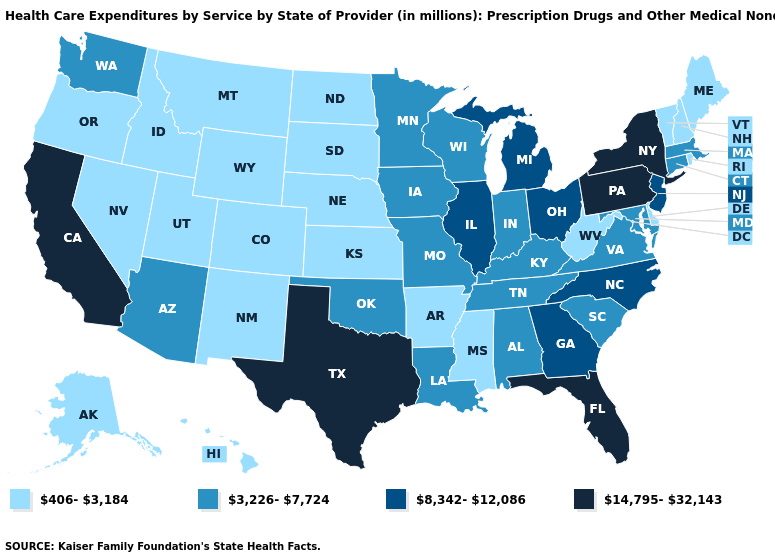Is the legend a continuous bar?
Concise answer only. No. What is the value of Maryland?
Give a very brief answer. 3,226-7,724. What is the value of Nebraska?
Be succinct. 406-3,184. What is the highest value in states that border Delaware?
Quick response, please. 14,795-32,143. Does Pennsylvania have the highest value in the Northeast?
Keep it brief. Yes. What is the highest value in the South ?
Be succinct. 14,795-32,143. Name the states that have a value in the range 406-3,184?
Give a very brief answer. Alaska, Arkansas, Colorado, Delaware, Hawaii, Idaho, Kansas, Maine, Mississippi, Montana, Nebraska, Nevada, New Hampshire, New Mexico, North Dakota, Oregon, Rhode Island, South Dakota, Utah, Vermont, West Virginia, Wyoming. Among the states that border Maryland , does Delaware have the lowest value?
Keep it brief. Yes. Name the states that have a value in the range 14,795-32,143?
Answer briefly. California, Florida, New York, Pennsylvania, Texas. Among the states that border Nevada , does Utah have the lowest value?
Answer briefly. Yes. Name the states that have a value in the range 8,342-12,086?
Give a very brief answer. Georgia, Illinois, Michigan, New Jersey, North Carolina, Ohio. Is the legend a continuous bar?
Give a very brief answer. No. Name the states that have a value in the range 3,226-7,724?
Quick response, please. Alabama, Arizona, Connecticut, Indiana, Iowa, Kentucky, Louisiana, Maryland, Massachusetts, Minnesota, Missouri, Oklahoma, South Carolina, Tennessee, Virginia, Washington, Wisconsin. Name the states that have a value in the range 3,226-7,724?
Quick response, please. Alabama, Arizona, Connecticut, Indiana, Iowa, Kentucky, Louisiana, Maryland, Massachusetts, Minnesota, Missouri, Oklahoma, South Carolina, Tennessee, Virginia, Washington, Wisconsin. Name the states that have a value in the range 8,342-12,086?
Write a very short answer. Georgia, Illinois, Michigan, New Jersey, North Carolina, Ohio. 